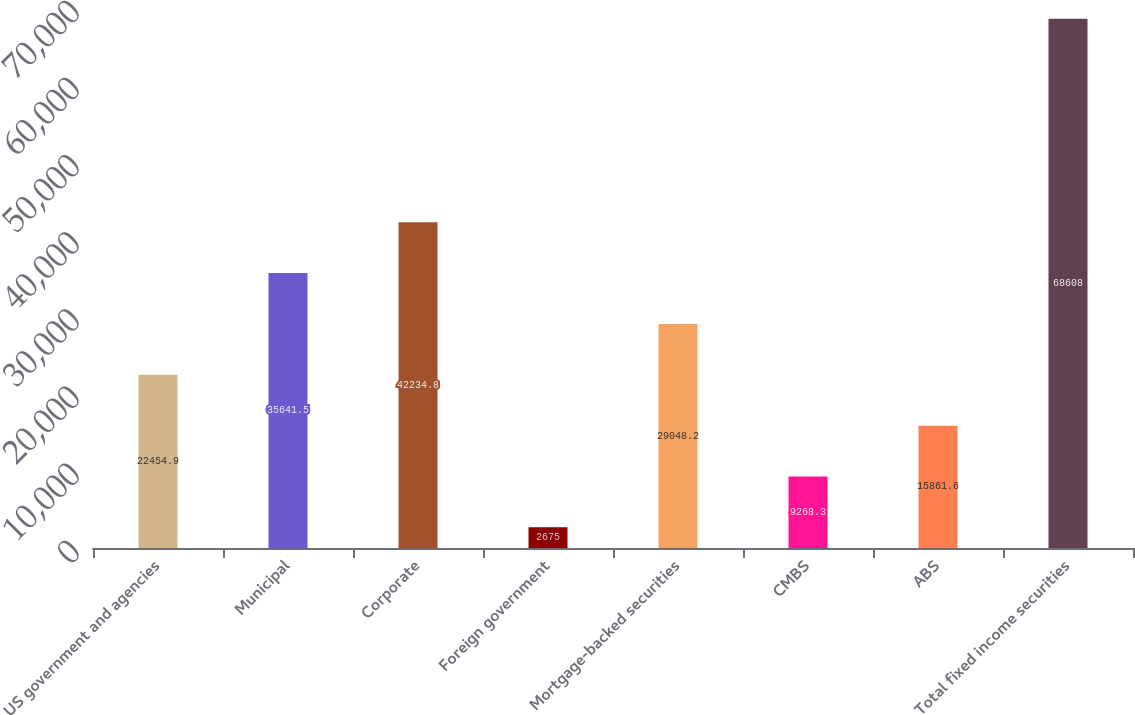Convert chart to OTSL. <chart><loc_0><loc_0><loc_500><loc_500><bar_chart><fcel>US government and agencies<fcel>Municipal<fcel>Corporate<fcel>Foreign government<fcel>Mortgage-backed securities<fcel>CMBS<fcel>ABS<fcel>Total fixed income securities<nl><fcel>22454.9<fcel>35641.5<fcel>42234.8<fcel>2675<fcel>29048.2<fcel>9268.3<fcel>15861.6<fcel>68608<nl></chart> 